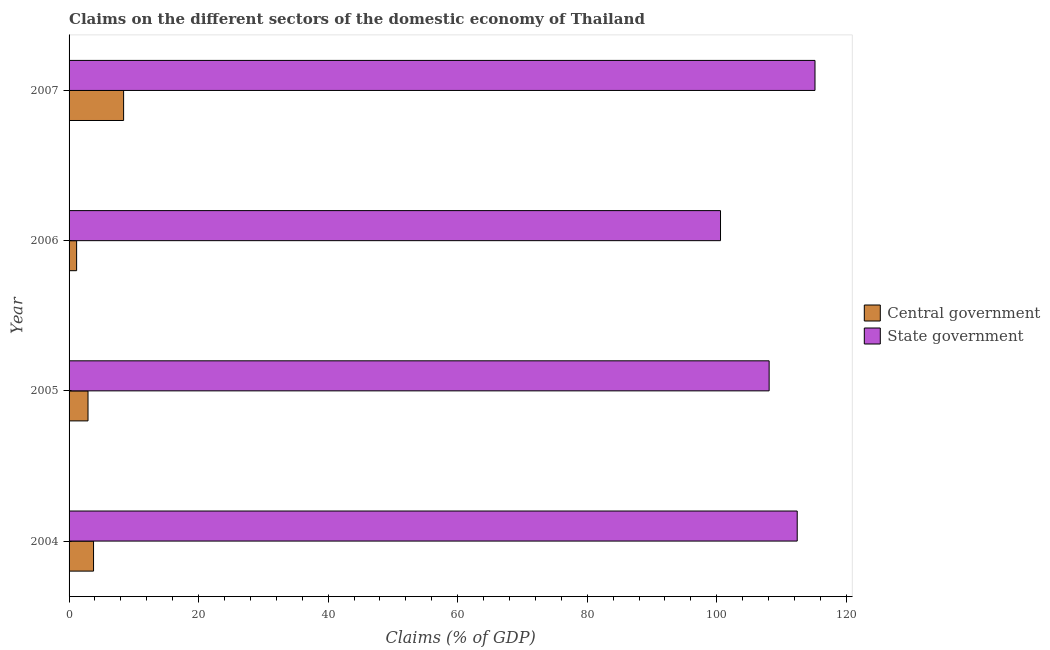How many different coloured bars are there?
Ensure brevity in your answer.  2. How many bars are there on the 4th tick from the top?
Provide a short and direct response. 2. What is the label of the 2nd group of bars from the top?
Give a very brief answer. 2006. What is the claims on state government in 2005?
Provide a short and direct response. 108.09. Across all years, what is the maximum claims on state government?
Keep it short and to the point. 115.17. Across all years, what is the minimum claims on central government?
Your answer should be compact. 1.17. In which year was the claims on central government maximum?
Your answer should be very brief. 2007. What is the total claims on state government in the graph?
Make the answer very short. 436.28. What is the difference between the claims on central government in 2005 and that in 2006?
Your answer should be very brief. 1.76. What is the difference between the claims on state government in 2005 and the claims on central government in 2006?
Keep it short and to the point. 106.93. What is the average claims on central government per year?
Offer a terse response. 4.07. In the year 2004, what is the difference between the claims on state government and claims on central government?
Keep it short and to the point. 108.65. What is the ratio of the claims on central government in 2006 to that in 2007?
Your response must be concise. 0.14. Is the claims on central government in 2004 less than that in 2006?
Keep it short and to the point. No. What is the difference between the highest and the second highest claims on central government?
Ensure brevity in your answer.  4.64. What is the difference between the highest and the lowest claims on state government?
Provide a succinct answer. 14.59. In how many years, is the claims on state government greater than the average claims on state government taken over all years?
Your response must be concise. 2. What does the 2nd bar from the top in 2007 represents?
Ensure brevity in your answer.  Central government. What does the 1st bar from the bottom in 2007 represents?
Provide a succinct answer. Central government. How many bars are there?
Ensure brevity in your answer.  8. What is the difference between two consecutive major ticks on the X-axis?
Offer a terse response. 20. Are the values on the major ticks of X-axis written in scientific E-notation?
Give a very brief answer. No. Does the graph contain any zero values?
Your answer should be compact. No. How many legend labels are there?
Offer a very short reply. 2. How are the legend labels stacked?
Provide a succinct answer. Vertical. What is the title of the graph?
Your answer should be very brief. Claims on the different sectors of the domestic economy of Thailand. Does "Taxes on profits and capital gains" appear as one of the legend labels in the graph?
Give a very brief answer. No. What is the label or title of the X-axis?
Offer a very short reply. Claims (% of GDP). What is the label or title of the Y-axis?
Offer a very short reply. Year. What is the Claims (% of GDP) of Central government in 2004?
Your answer should be compact. 3.78. What is the Claims (% of GDP) of State government in 2004?
Offer a very short reply. 112.43. What is the Claims (% of GDP) of Central government in 2005?
Offer a terse response. 2.93. What is the Claims (% of GDP) of State government in 2005?
Offer a very short reply. 108.09. What is the Claims (% of GDP) of Central government in 2006?
Give a very brief answer. 1.17. What is the Claims (% of GDP) of State government in 2006?
Give a very brief answer. 100.58. What is the Claims (% of GDP) in Central government in 2007?
Ensure brevity in your answer.  8.42. What is the Claims (% of GDP) of State government in 2007?
Offer a terse response. 115.17. Across all years, what is the maximum Claims (% of GDP) of Central government?
Offer a terse response. 8.42. Across all years, what is the maximum Claims (% of GDP) in State government?
Provide a short and direct response. 115.17. Across all years, what is the minimum Claims (% of GDP) of Central government?
Provide a succinct answer. 1.17. Across all years, what is the minimum Claims (% of GDP) of State government?
Your answer should be very brief. 100.58. What is the total Claims (% of GDP) of Central government in the graph?
Your response must be concise. 16.29. What is the total Claims (% of GDP) in State government in the graph?
Your response must be concise. 436.28. What is the difference between the Claims (% of GDP) in Central government in 2004 and that in 2005?
Ensure brevity in your answer.  0.85. What is the difference between the Claims (% of GDP) of State government in 2004 and that in 2005?
Make the answer very short. 4.33. What is the difference between the Claims (% of GDP) in Central government in 2004 and that in 2006?
Provide a succinct answer. 2.61. What is the difference between the Claims (% of GDP) of State government in 2004 and that in 2006?
Give a very brief answer. 11.84. What is the difference between the Claims (% of GDP) of Central government in 2004 and that in 2007?
Offer a terse response. -4.64. What is the difference between the Claims (% of GDP) of State government in 2004 and that in 2007?
Your answer should be compact. -2.74. What is the difference between the Claims (% of GDP) in Central government in 2005 and that in 2006?
Your response must be concise. 1.76. What is the difference between the Claims (% of GDP) of State government in 2005 and that in 2006?
Provide a short and direct response. 7.51. What is the difference between the Claims (% of GDP) in Central government in 2005 and that in 2007?
Offer a very short reply. -5.49. What is the difference between the Claims (% of GDP) in State government in 2005 and that in 2007?
Your response must be concise. -7.08. What is the difference between the Claims (% of GDP) of Central government in 2006 and that in 2007?
Make the answer very short. -7.25. What is the difference between the Claims (% of GDP) in State government in 2006 and that in 2007?
Offer a very short reply. -14.59. What is the difference between the Claims (% of GDP) in Central government in 2004 and the Claims (% of GDP) in State government in 2005?
Ensure brevity in your answer.  -104.31. What is the difference between the Claims (% of GDP) in Central government in 2004 and the Claims (% of GDP) in State government in 2006?
Provide a short and direct response. -96.81. What is the difference between the Claims (% of GDP) in Central government in 2004 and the Claims (% of GDP) in State government in 2007?
Make the answer very short. -111.39. What is the difference between the Claims (% of GDP) in Central government in 2005 and the Claims (% of GDP) in State government in 2006?
Your response must be concise. -97.66. What is the difference between the Claims (% of GDP) in Central government in 2005 and the Claims (% of GDP) in State government in 2007?
Ensure brevity in your answer.  -112.25. What is the difference between the Claims (% of GDP) of Central government in 2006 and the Claims (% of GDP) of State government in 2007?
Keep it short and to the point. -114.01. What is the average Claims (% of GDP) of Central government per year?
Give a very brief answer. 4.07. What is the average Claims (% of GDP) in State government per year?
Ensure brevity in your answer.  109.07. In the year 2004, what is the difference between the Claims (% of GDP) of Central government and Claims (% of GDP) of State government?
Offer a terse response. -108.65. In the year 2005, what is the difference between the Claims (% of GDP) in Central government and Claims (% of GDP) in State government?
Ensure brevity in your answer.  -105.17. In the year 2006, what is the difference between the Claims (% of GDP) of Central government and Claims (% of GDP) of State government?
Your answer should be very brief. -99.42. In the year 2007, what is the difference between the Claims (% of GDP) of Central government and Claims (% of GDP) of State government?
Ensure brevity in your answer.  -106.75. What is the ratio of the Claims (% of GDP) of Central government in 2004 to that in 2005?
Make the answer very short. 1.29. What is the ratio of the Claims (% of GDP) in State government in 2004 to that in 2005?
Give a very brief answer. 1.04. What is the ratio of the Claims (% of GDP) in Central government in 2004 to that in 2006?
Offer a very short reply. 3.24. What is the ratio of the Claims (% of GDP) of State government in 2004 to that in 2006?
Offer a terse response. 1.12. What is the ratio of the Claims (% of GDP) in Central government in 2004 to that in 2007?
Offer a terse response. 0.45. What is the ratio of the Claims (% of GDP) of State government in 2004 to that in 2007?
Your answer should be compact. 0.98. What is the ratio of the Claims (% of GDP) in Central government in 2005 to that in 2006?
Provide a short and direct response. 2.51. What is the ratio of the Claims (% of GDP) in State government in 2005 to that in 2006?
Ensure brevity in your answer.  1.07. What is the ratio of the Claims (% of GDP) in Central government in 2005 to that in 2007?
Provide a short and direct response. 0.35. What is the ratio of the Claims (% of GDP) in State government in 2005 to that in 2007?
Provide a short and direct response. 0.94. What is the ratio of the Claims (% of GDP) of Central government in 2006 to that in 2007?
Your answer should be compact. 0.14. What is the ratio of the Claims (% of GDP) of State government in 2006 to that in 2007?
Offer a terse response. 0.87. What is the difference between the highest and the second highest Claims (% of GDP) of Central government?
Provide a succinct answer. 4.64. What is the difference between the highest and the second highest Claims (% of GDP) of State government?
Offer a very short reply. 2.74. What is the difference between the highest and the lowest Claims (% of GDP) in Central government?
Offer a terse response. 7.25. What is the difference between the highest and the lowest Claims (% of GDP) in State government?
Your response must be concise. 14.59. 